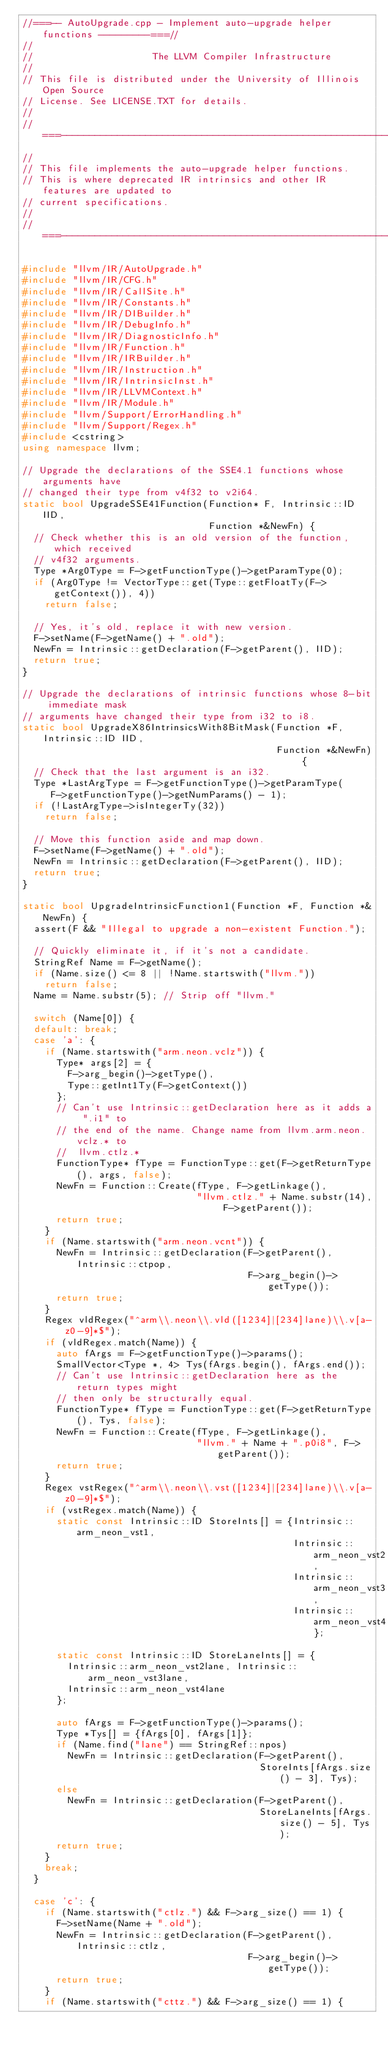Convert code to text. <code><loc_0><loc_0><loc_500><loc_500><_C++_>//===-- AutoUpgrade.cpp - Implement auto-upgrade helper functions ---------===//
//
//                     The LLVM Compiler Infrastructure
//
// This file is distributed under the University of Illinois Open Source
// License. See LICENSE.TXT for details.
//
//===----------------------------------------------------------------------===//
//
// This file implements the auto-upgrade helper functions.
// This is where deprecated IR intrinsics and other IR features are updated to
// current specifications.
//
//===----------------------------------------------------------------------===//

#include "llvm/IR/AutoUpgrade.h"
#include "llvm/IR/CFG.h"
#include "llvm/IR/CallSite.h"
#include "llvm/IR/Constants.h"
#include "llvm/IR/DIBuilder.h"
#include "llvm/IR/DebugInfo.h"
#include "llvm/IR/DiagnosticInfo.h"
#include "llvm/IR/Function.h"
#include "llvm/IR/IRBuilder.h"
#include "llvm/IR/Instruction.h"
#include "llvm/IR/IntrinsicInst.h"
#include "llvm/IR/LLVMContext.h"
#include "llvm/IR/Module.h"
#include "llvm/Support/ErrorHandling.h"
#include "llvm/Support/Regex.h"
#include <cstring>
using namespace llvm;

// Upgrade the declarations of the SSE4.1 functions whose arguments have
// changed their type from v4f32 to v2i64.
static bool UpgradeSSE41Function(Function* F, Intrinsic::ID IID,
                                 Function *&NewFn) {
  // Check whether this is an old version of the function, which received
  // v4f32 arguments.
  Type *Arg0Type = F->getFunctionType()->getParamType(0);
  if (Arg0Type != VectorType::get(Type::getFloatTy(F->getContext()), 4))
    return false;

  // Yes, it's old, replace it with new version.
  F->setName(F->getName() + ".old");
  NewFn = Intrinsic::getDeclaration(F->getParent(), IID);
  return true;
}

// Upgrade the declarations of intrinsic functions whose 8-bit immediate mask
// arguments have changed their type from i32 to i8.
static bool UpgradeX86IntrinsicsWith8BitMask(Function *F, Intrinsic::ID IID,
                                             Function *&NewFn) {
  // Check that the last argument is an i32.
  Type *LastArgType = F->getFunctionType()->getParamType(
     F->getFunctionType()->getNumParams() - 1);
  if (!LastArgType->isIntegerTy(32))
    return false;

  // Move this function aside and map down.
  F->setName(F->getName() + ".old");
  NewFn = Intrinsic::getDeclaration(F->getParent(), IID);
  return true;
}

static bool UpgradeIntrinsicFunction1(Function *F, Function *&NewFn) {
  assert(F && "Illegal to upgrade a non-existent Function.");

  // Quickly eliminate it, if it's not a candidate.
  StringRef Name = F->getName();
  if (Name.size() <= 8 || !Name.startswith("llvm."))
    return false;
  Name = Name.substr(5); // Strip off "llvm."

  switch (Name[0]) {
  default: break;
  case 'a': {
    if (Name.startswith("arm.neon.vclz")) {
      Type* args[2] = {
        F->arg_begin()->getType(),
        Type::getInt1Ty(F->getContext())
      };
      // Can't use Intrinsic::getDeclaration here as it adds a ".i1" to
      // the end of the name. Change name from llvm.arm.neon.vclz.* to
      //  llvm.ctlz.*
      FunctionType* fType = FunctionType::get(F->getReturnType(), args, false);
      NewFn = Function::Create(fType, F->getLinkage(),
                               "llvm.ctlz." + Name.substr(14), F->getParent());
      return true;
    }
    if (Name.startswith("arm.neon.vcnt")) {
      NewFn = Intrinsic::getDeclaration(F->getParent(), Intrinsic::ctpop,
                                        F->arg_begin()->getType());
      return true;
    }
    Regex vldRegex("^arm\\.neon\\.vld([1234]|[234]lane)\\.v[a-z0-9]*$");
    if (vldRegex.match(Name)) {
      auto fArgs = F->getFunctionType()->params();
      SmallVector<Type *, 4> Tys(fArgs.begin(), fArgs.end());
      // Can't use Intrinsic::getDeclaration here as the return types might
      // then only be structurally equal.
      FunctionType* fType = FunctionType::get(F->getReturnType(), Tys, false);
      NewFn = Function::Create(fType, F->getLinkage(),
                               "llvm." + Name + ".p0i8", F->getParent());
      return true;
    }
    Regex vstRegex("^arm\\.neon\\.vst([1234]|[234]lane)\\.v[a-z0-9]*$");
    if (vstRegex.match(Name)) {
      static const Intrinsic::ID StoreInts[] = {Intrinsic::arm_neon_vst1,
                                                Intrinsic::arm_neon_vst2,
                                                Intrinsic::arm_neon_vst3,
                                                Intrinsic::arm_neon_vst4};

      static const Intrinsic::ID StoreLaneInts[] = {
        Intrinsic::arm_neon_vst2lane, Intrinsic::arm_neon_vst3lane,
        Intrinsic::arm_neon_vst4lane
      };

      auto fArgs = F->getFunctionType()->params();
      Type *Tys[] = {fArgs[0], fArgs[1]};
      if (Name.find("lane") == StringRef::npos)
        NewFn = Intrinsic::getDeclaration(F->getParent(),
                                          StoreInts[fArgs.size() - 3], Tys);
      else
        NewFn = Intrinsic::getDeclaration(F->getParent(),
                                          StoreLaneInts[fArgs.size() - 5], Tys);
      return true;
    }
    break;
  }

  case 'c': {
    if (Name.startswith("ctlz.") && F->arg_size() == 1) {
      F->setName(Name + ".old");
      NewFn = Intrinsic::getDeclaration(F->getParent(), Intrinsic::ctlz,
                                        F->arg_begin()->getType());
      return true;
    }
    if (Name.startswith("cttz.") && F->arg_size() == 1) {</code> 